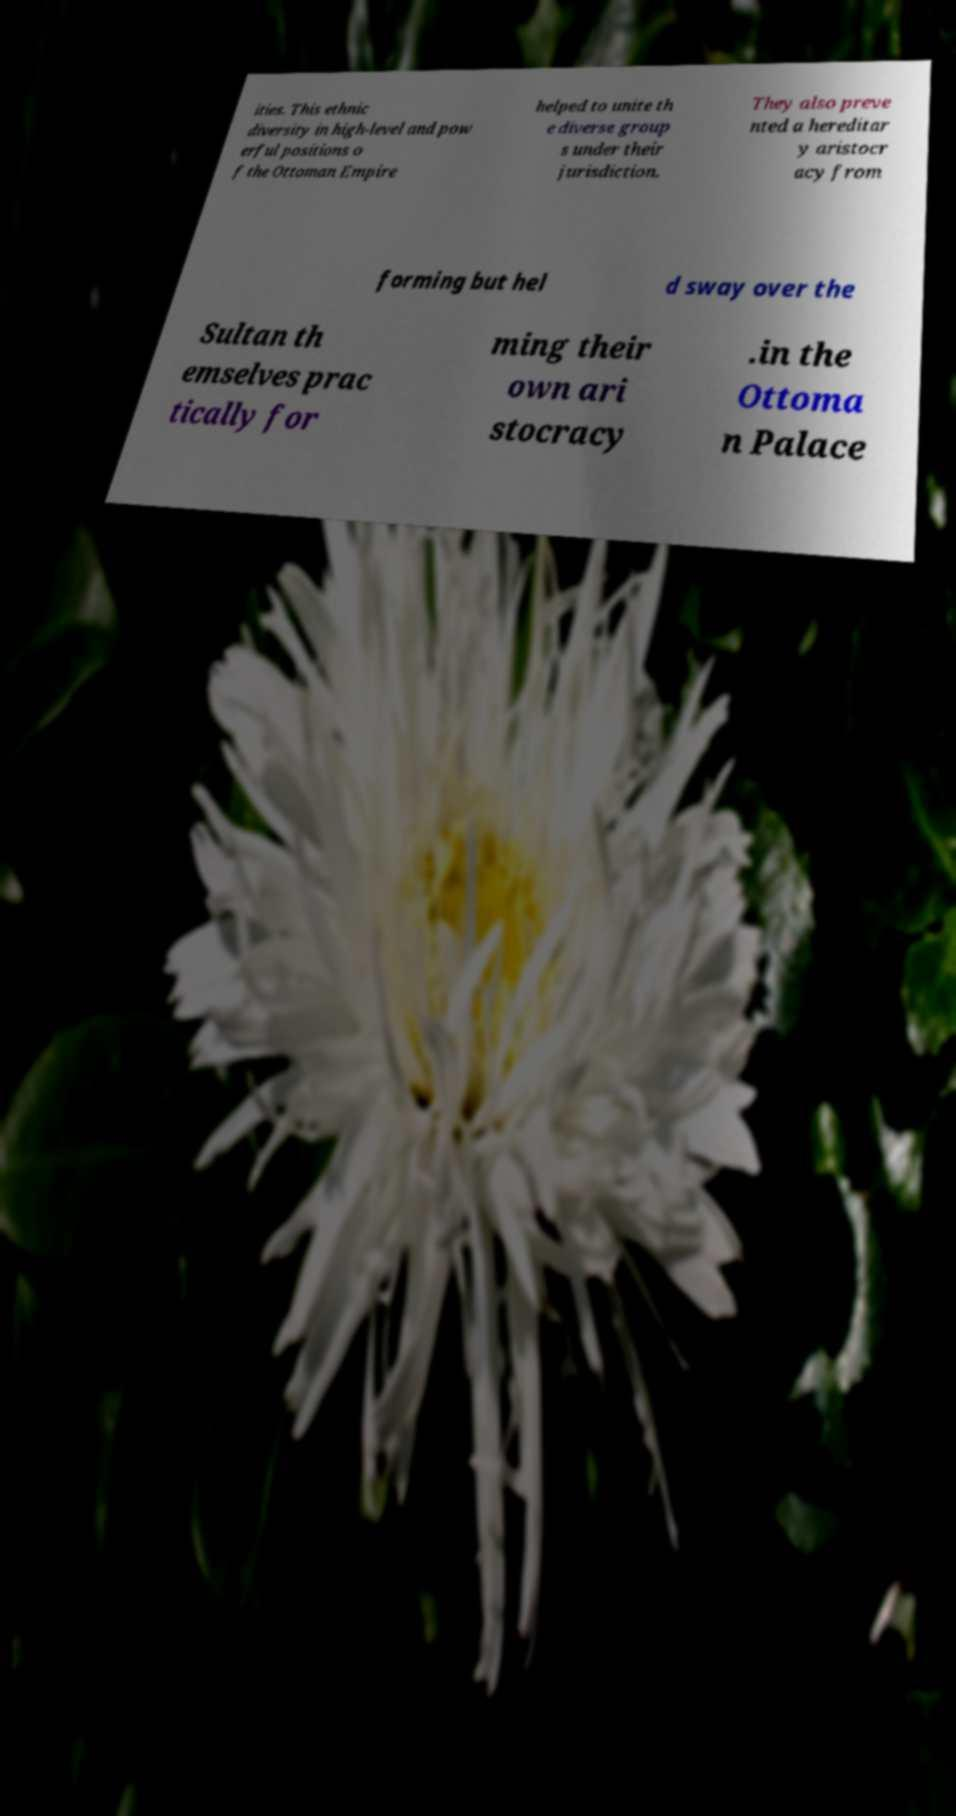Can you read and provide the text displayed in the image?This photo seems to have some interesting text. Can you extract and type it out for me? ities. This ethnic diversity in high-level and pow erful positions o f the Ottoman Empire helped to unite th e diverse group s under their jurisdiction. They also preve nted a hereditar y aristocr acy from forming but hel d sway over the Sultan th emselves prac tically for ming their own ari stocracy .in the Ottoma n Palace 